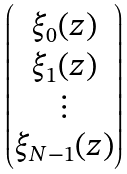<formula> <loc_0><loc_0><loc_500><loc_500>\begin{pmatrix} \xi _ { 0 } ( z ) \\ \xi _ { 1 } ( z ) \\ \vdots \\ \xi _ { N - 1 } ( z ) \end{pmatrix}</formula> 